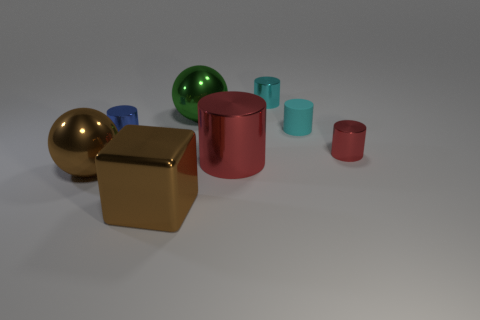Are the sphere behind the small blue object and the brown cube made of the same material?
Provide a short and direct response. Yes. What is the material of the red cylinder that is left of the small cyan shiny cylinder?
Your answer should be very brief. Metal. How big is the brown object that is on the left side of the big brown object that is right of the blue metal object?
Your answer should be compact. Large. What number of yellow matte spheres have the same size as the cyan matte thing?
Your answer should be very brief. 0. There is a shiny cylinder that is left of the large red shiny cylinder; does it have the same color as the big block that is on the left side of the cyan metal cylinder?
Offer a terse response. No. Are there any small cyan rubber things to the left of the cyan metal cylinder?
Ensure brevity in your answer.  No. What color is the metallic cylinder that is both in front of the blue metallic object and to the right of the big shiny cylinder?
Provide a short and direct response. Red. Are there any tiny cylinders that have the same color as the large cube?
Your answer should be very brief. No. Does the sphere that is in front of the green shiny ball have the same material as the sphere that is right of the brown metallic cube?
Ensure brevity in your answer.  Yes. There is a red metallic cylinder on the right side of the small rubber thing; what size is it?
Your answer should be very brief. Small. 